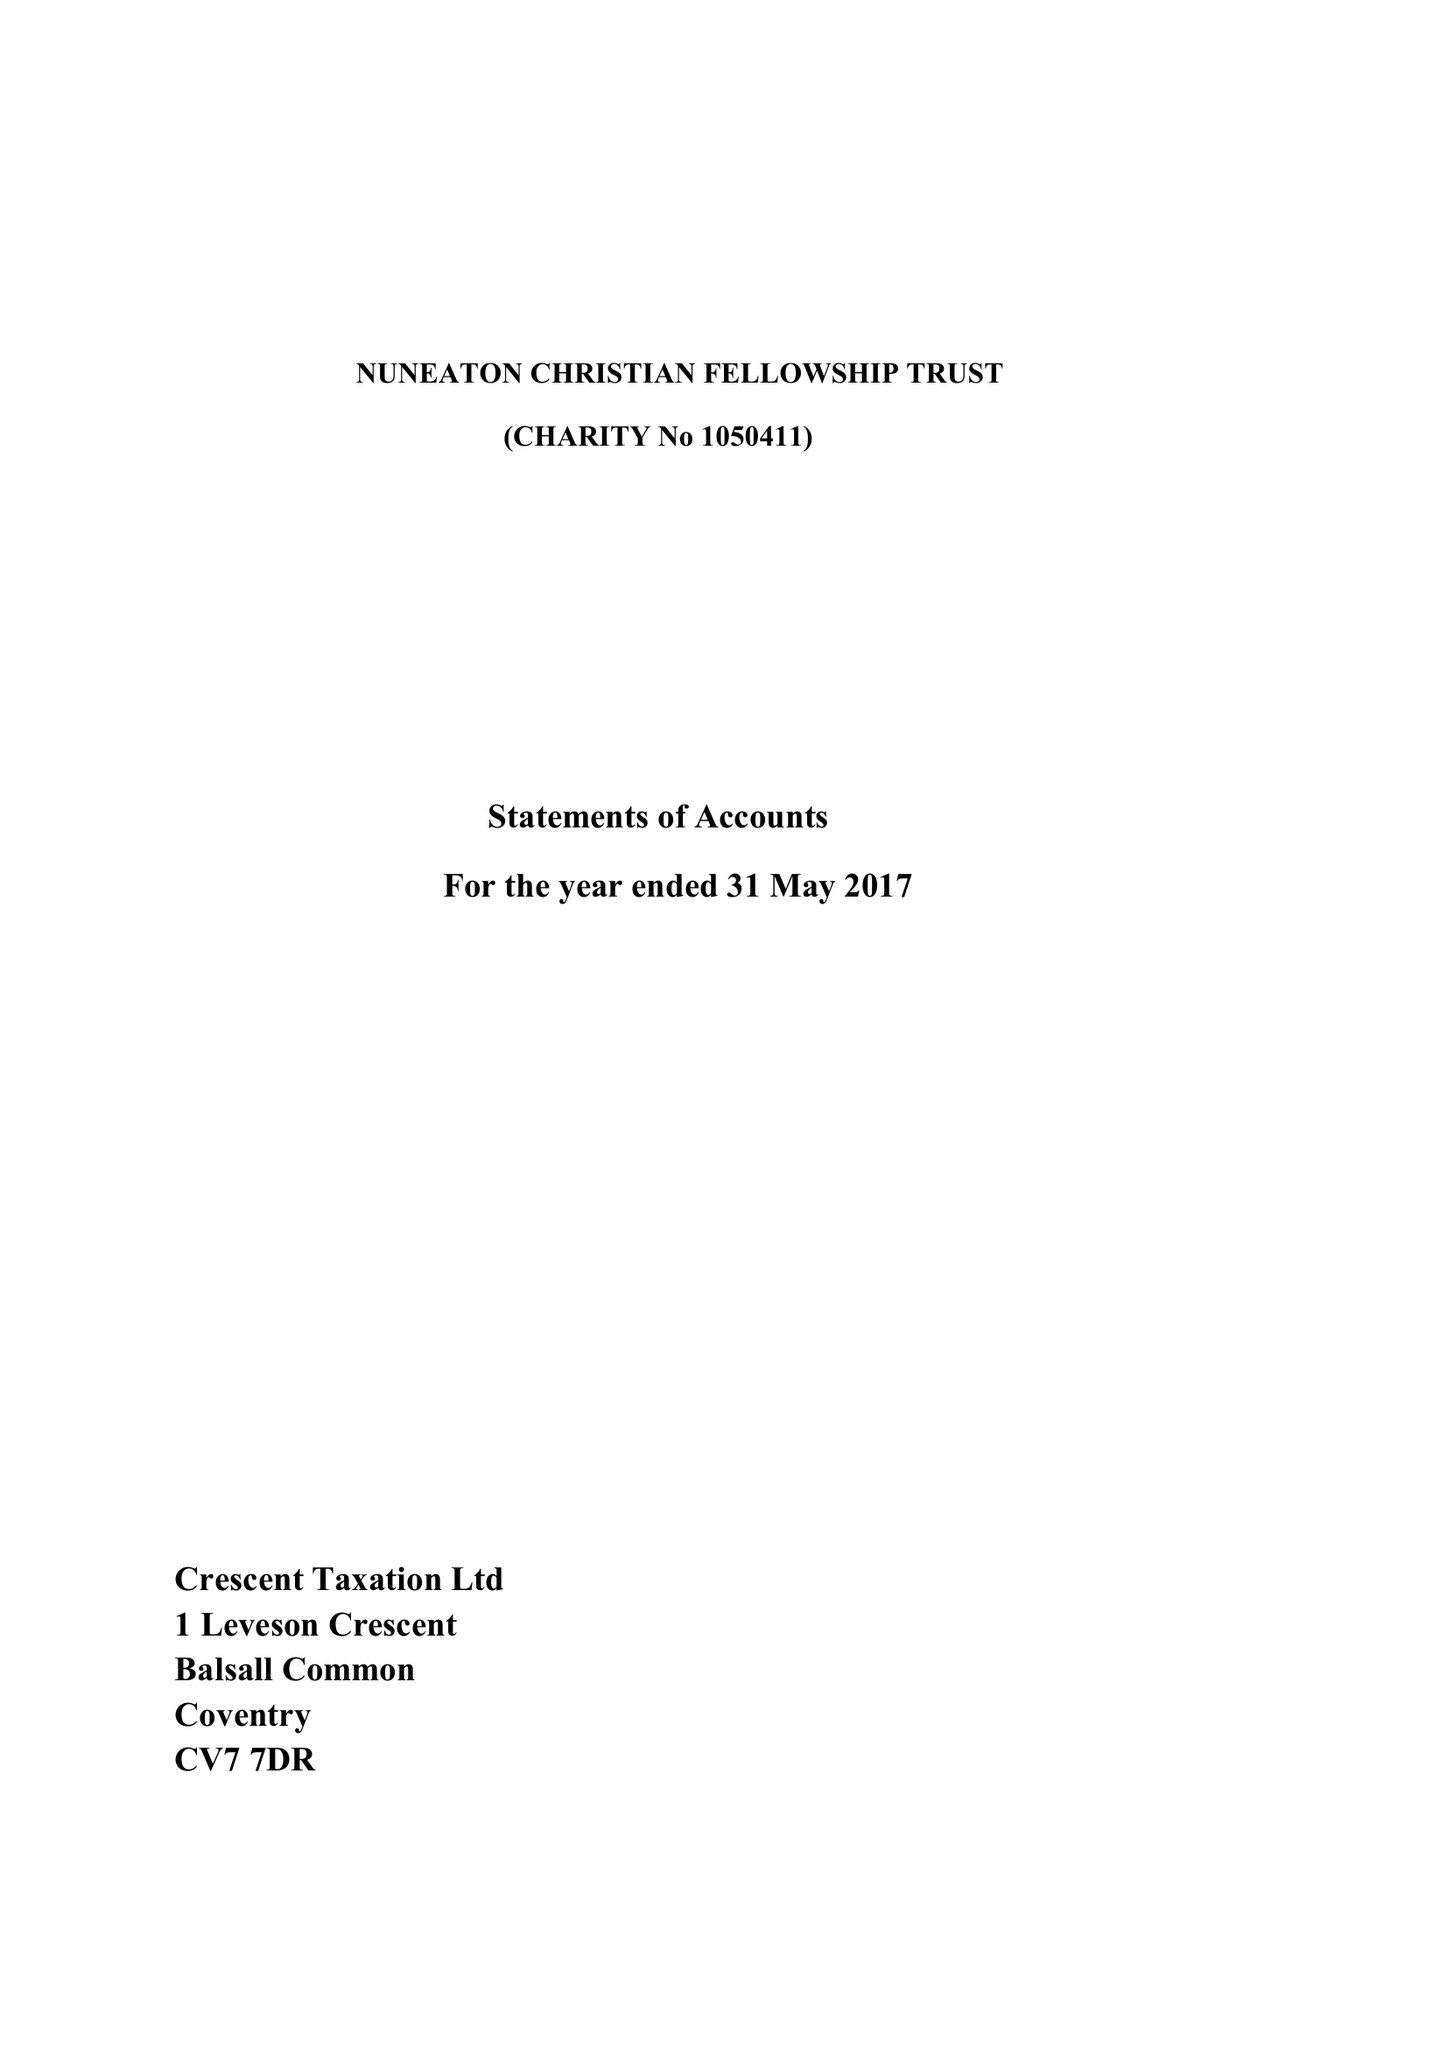What is the value for the charity_name?
Answer the question using a single word or phrase. Nuneaton Christian Fellowship Trust 